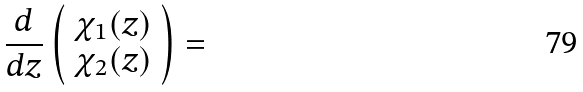Convert formula to latex. <formula><loc_0><loc_0><loc_500><loc_500>\frac { d } { d z } \left ( \begin{array} { r r } \chi _ { 1 } ( z ) \\ \chi _ { 2 } ( z ) \end{array} \right ) =</formula> 